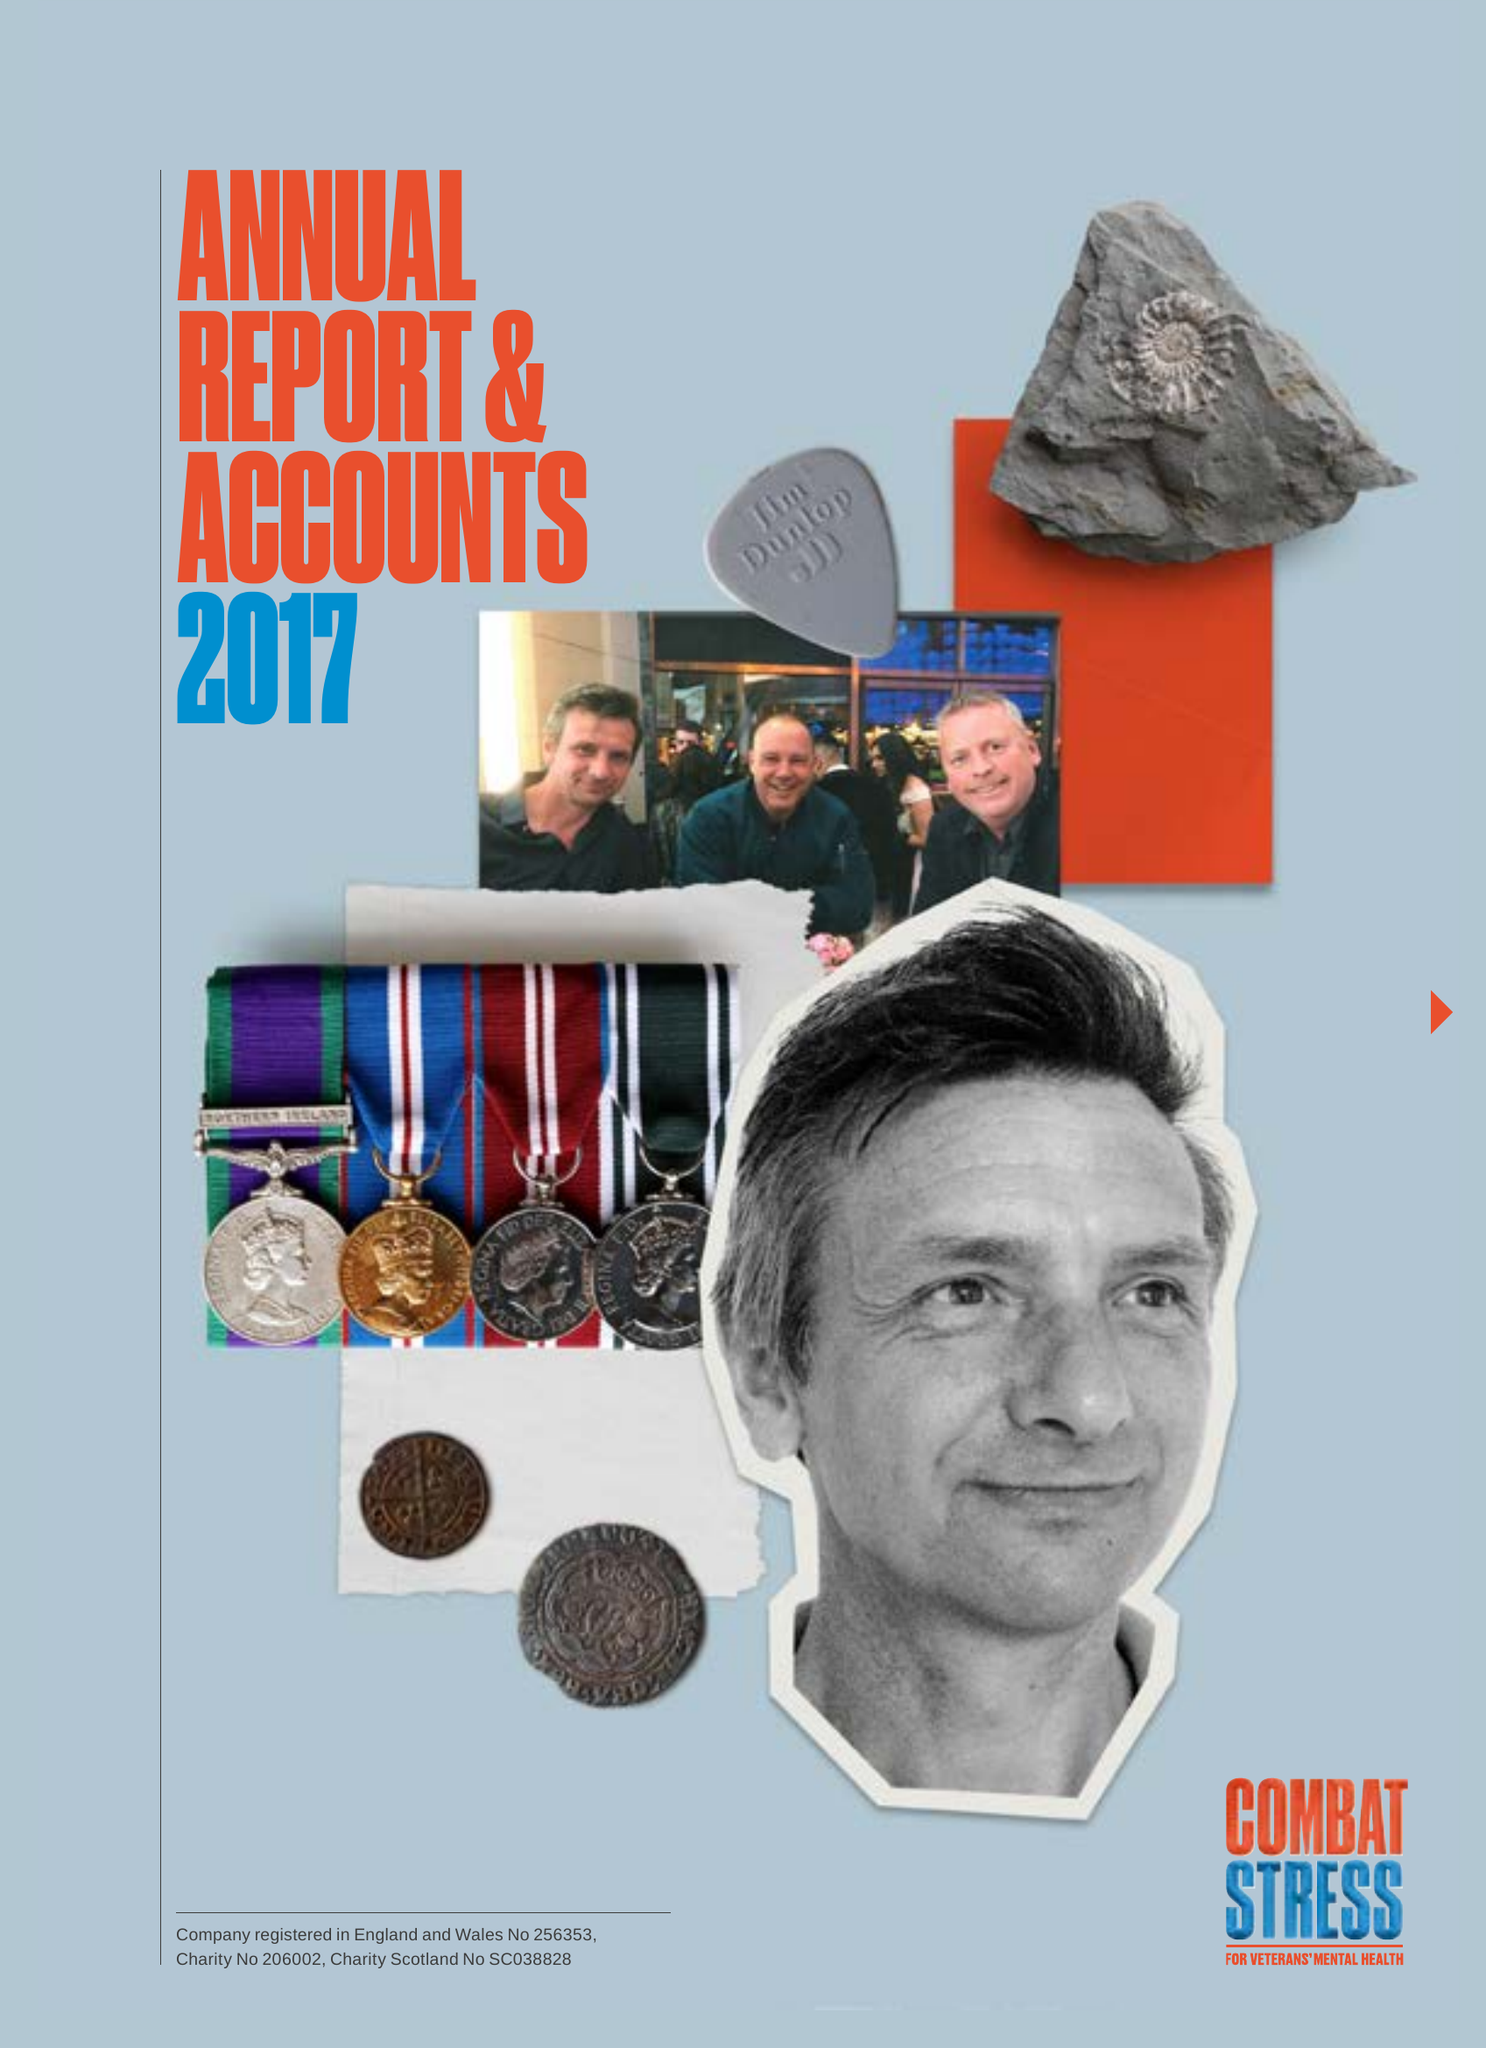What is the value for the charity_name?
Answer the question using a single word or phrase. Combat Stress 